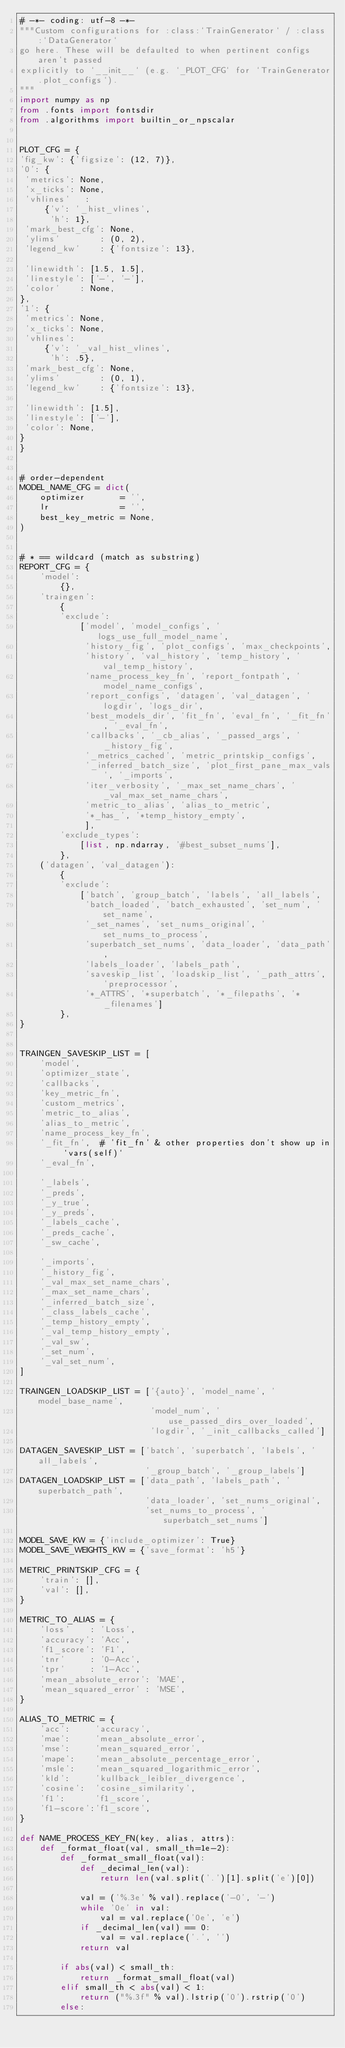<code> <loc_0><loc_0><loc_500><loc_500><_Python_># -*- coding: utf-8 -*-
"""Custom configurations for :class:`TrainGenerator` / :class:`DataGenerator`
go here. These will be defaulted to when pertinent configs aren't passed
explicitly to `__init__` (e.g. `_PLOT_CFG` for `TrainGenerator.plot_configs`).
"""
import numpy as np
from .fonts import fontsdir
from .algorithms import builtin_or_npscalar


PLOT_CFG = {
'fig_kw': {'figsize': (12, 7)},
'0': {
 'metrics': None,
 'x_ticks': None,
 'vhlines'   :
     {'v': '_hist_vlines',
      'h': 1},
 'mark_best_cfg': None,
 'ylims'        : (0, 2),
 'legend_kw'    : {'fontsize': 13},

 'linewidth': [1.5, 1.5],
 'linestyle': ['-', '-'],
 'color'    : None,
},
'1': {
 'metrics': None,
 'x_ticks': None,
 'vhlines':
     {'v': '_val_hist_vlines',
      'h': .5},
 'mark_best_cfg': None,
 'ylims'        : (0, 1),
 'legend_kw'    : {'fontsize': 13},

 'linewidth': [1.5],
 'linestyle': ['-'],
 'color': None,
}
}


# order-dependent
MODEL_NAME_CFG = dict(
    optimizer       = '',
    lr              = '',
    best_key_metric = None,
)


# * == wildcard (match as substring)
REPORT_CFG = {
    'model':
        {},
    'traingen':
        {
        'exclude':
            ['model', 'model_configs', 'logs_use_full_model_name',
             'history_fig', 'plot_configs', 'max_checkpoints',
             'history', 'val_history', 'temp_history', 'val_temp_history',
             'name_process_key_fn', 'report_fontpath', 'model_name_configs',
             'report_configs', 'datagen', 'val_datagen', 'logdir', 'logs_dir',
             'best_models_dir', 'fit_fn', 'eval_fn', '_fit_fn', '_eval_fn',
             'callbacks', '_cb_alias', '_passed_args', '_history_fig',
             '_metrics_cached', 'metric_printskip_configs',
             '_inferred_batch_size', 'plot_first_pane_max_vals', '_imports',
             'iter_verbosity', '_max_set_name_chars', '_val_max_set_name_chars',
             'metric_to_alias', 'alias_to_metric',
             '*_has_', '*temp_history_empty',
             ],
        'exclude_types':
            [list, np.ndarray, '#best_subset_nums'],
        },
    ('datagen', 'val_datagen'):
        {
        'exclude':
            ['batch', 'group_batch', 'labels', 'all_labels',
             'batch_loaded', 'batch_exhausted', 'set_num', 'set_name',
             '_set_names', 'set_nums_original', 'set_nums_to_process',
             'superbatch_set_nums', 'data_loader', 'data_path',
             'labels_loader', 'labels_path',
             'saveskip_list', 'loadskip_list', '_path_attrs', 'preprocessor',
             '*_ATTRS', '*superbatch', '*_filepaths', '*_filenames']
        },
}


TRAINGEN_SAVESKIP_LIST = [
    'model',
    'optimizer_state',
    'callbacks',
    'key_metric_fn',
    'custom_metrics',
    'metric_to_alias',
    'alias_to_metric',
    'name_process_key_fn',
    '_fit_fn',  # 'fit_fn' & other properties don't show up in `vars(self)`
    '_eval_fn',

    '_labels',
    '_preds',
    '_y_true',
    '_y_preds',
    '_labels_cache',
    '_preds_cache',
    '_sw_cache',

    '_imports',
    '_history_fig',
    '_val_max_set_name_chars',
    '_max_set_name_chars',
    '_inferred_batch_size',
    '_class_labels_cache',
    '_temp_history_empty',
    '_val_temp_history_empty',
    '_val_sw',
    '_set_num',
    '_val_set_num',
]

TRAINGEN_LOADSKIP_LIST = ['{auto}', 'model_name', 'model_base_name',
                          'model_num', 'use_passed_dirs_over_loaded',
                          'logdir', '_init_callbacks_called']

DATAGEN_SAVESKIP_LIST = ['batch', 'superbatch', 'labels', 'all_labels',
                         '_group_batch', '_group_labels']
DATAGEN_LOADSKIP_LIST = ['data_path', 'labels_path', 'superbatch_path',
                         'data_loader', 'set_nums_original',
                         'set_nums_to_process', 'superbatch_set_nums']

MODEL_SAVE_KW = {'include_optimizer': True}
MODEL_SAVE_WEIGHTS_KW = {'save_format': 'h5'}

METRIC_PRINTSKIP_CFG = {
    'train': [],
    'val': [],
}

METRIC_TO_ALIAS = {
    'loss'    : 'Loss',
    'accuracy': 'Acc',
    'f1_score': 'F1',
    'tnr'     : '0-Acc',
    'tpr'     : '1-Acc',
    'mean_absolute_error': 'MAE',
    'mean_squared_error' : 'MSE',
}

ALIAS_TO_METRIC = {
    'acc':     'accuracy',
    'mae':     'mean_absolute_error',
    'mse':     'mean_squared_error',
    'mape':    'mean_absolute_percentage_error',
    'msle':    'mean_squared_logarithmic_error',
    'kld':     'kullback_leibler_divergence',
    'cosine':  'cosine_similarity',
    'f1':      'f1_score',
    'f1-score':'f1_score',
}

def NAME_PROCESS_KEY_FN(key, alias, attrs):
    def _format_float(val, small_th=1e-2):
        def _format_small_float(val):
            def _decimal_len(val):
                return len(val.split('.')[1].split('e')[0])

            val = ('%.3e' % val).replace('-0', '-')
            while '0e' in val:
                val = val.replace('0e', 'e')
            if _decimal_len(val) == 0:
                val = val.replace('.', '')
            return val

        if abs(val) < small_th:
            return _format_small_float(val)
        elif small_th < abs(val) < 1:
            return ("%.3f" % val).lstrip('0').rstrip('0')
        else:</code> 